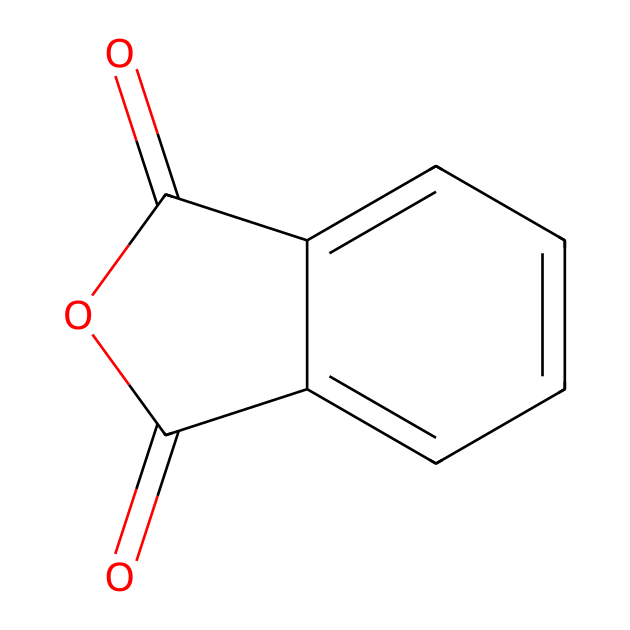What is the name of this chemical? The SMILES representation given corresponds to phthalic anhydride, which is a well-known chemical compound used in various applications, including coatings.
Answer: phthalic anhydride How many carbon atoms are in phthalic anhydride? By analyzing the structure represented by the SMILES, we can count the carbon atoms. In the 6-membered aromatic ring and the carbonyl groups, there are a total of 8 carbon atoms present.
Answer: 8 How many oxygen atoms does phthalic anhydride contain? The SMILES indicates two carbonyl groups (each contributing one oxygen) and one additional oxygen in the anhydride structure, totaling 3 oxygen atoms in phthalic anhydride.
Answer: 3 What type of chemical bond connects the carbon atoms in this structure? The structure has both single and double bonds connecting the carbon atoms; specifically, the aromatic ring contains conjugated double bonds, while the carbonyl groups contain double bonds as well.
Answer: double bonds What type of functional groups are present in phthalic anhydride? Upon examining the structure, it is clear that phthalic anhydride features an anhydride functional group, which is a distinctive attribute for this chemical.
Answer: anhydride Is phthalic anhydride classified as a cyclic or acyclic compound? The presence of a cyclic arrangement in the structure indicates that phthalic anhydride is categorized as a cyclic compound, as it forms a ring structure.
Answer: cyclic What is the primary use of phthalic anhydride in computer hardware coatings? Phthalic anhydride is often used in the production of polyester resins and is utilized as a curing agent or modifier to improve adhesion and durability of coatings in electronics.
Answer: coatings 